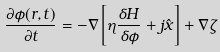Convert formula to latex. <formula><loc_0><loc_0><loc_500><loc_500>\frac { \partial \phi ( { r } , t ) } { \partial t } = - \nabla \left [ \eta \frac { \delta H } { \delta \phi } + j { \hat { x } } \right ] + \nabla \zeta</formula> 